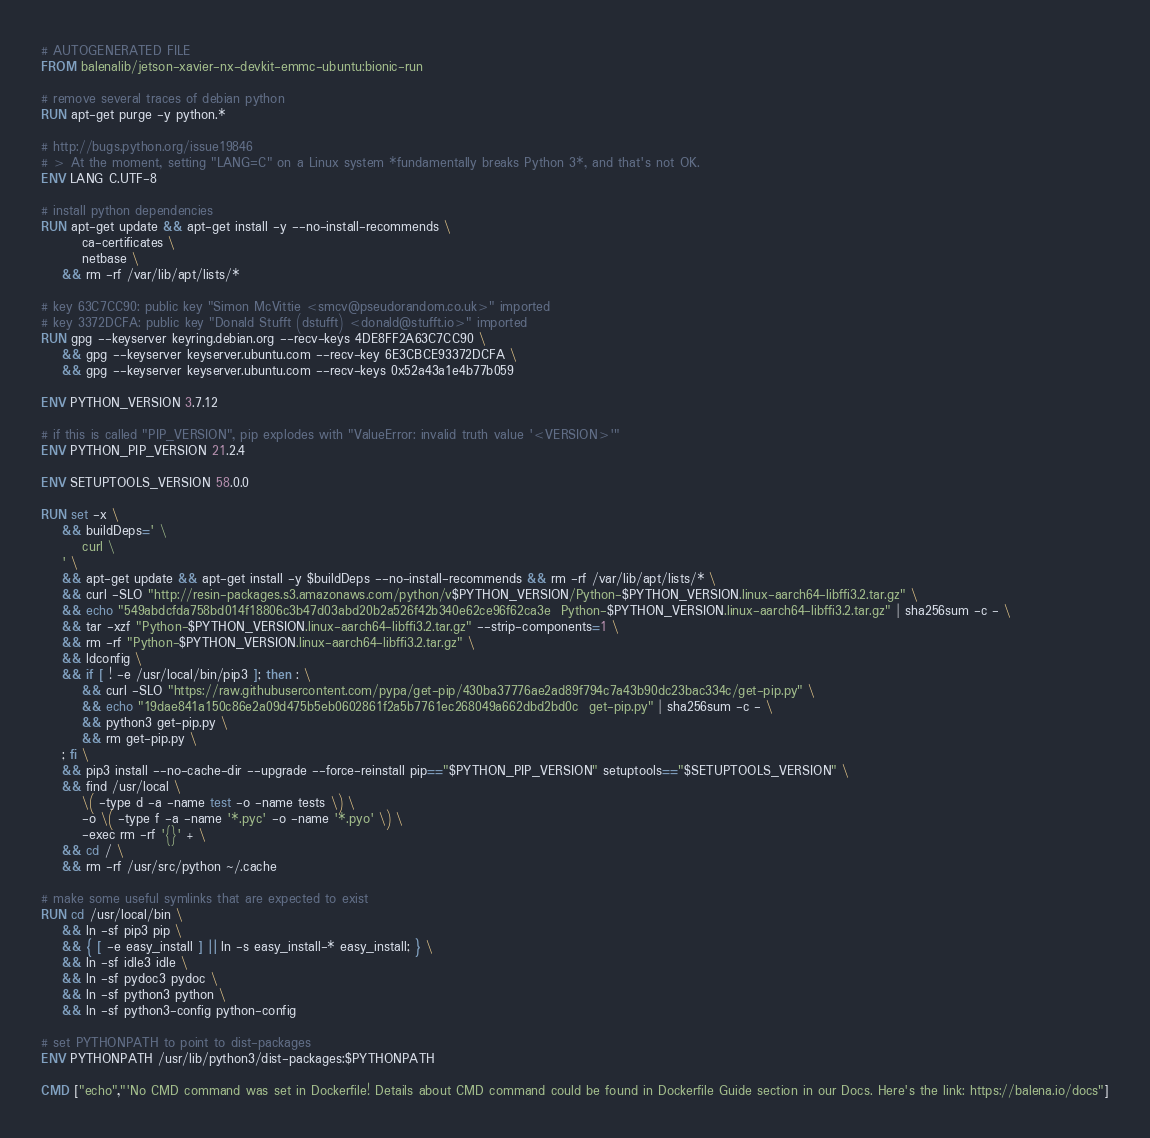<code> <loc_0><loc_0><loc_500><loc_500><_Dockerfile_># AUTOGENERATED FILE
FROM balenalib/jetson-xavier-nx-devkit-emmc-ubuntu:bionic-run

# remove several traces of debian python
RUN apt-get purge -y python.*

# http://bugs.python.org/issue19846
# > At the moment, setting "LANG=C" on a Linux system *fundamentally breaks Python 3*, and that's not OK.
ENV LANG C.UTF-8

# install python dependencies
RUN apt-get update && apt-get install -y --no-install-recommends \
		ca-certificates \
		netbase \
	&& rm -rf /var/lib/apt/lists/*

# key 63C7CC90: public key "Simon McVittie <smcv@pseudorandom.co.uk>" imported
# key 3372DCFA: public key "Donald Stufft (dstufft) <donald@stufft.io>" imported
RUN gpg --keyserver keyring.debian.org --recv-keys 4DE8FF2A63C7CC90 \
	&& gpg --keyserver keyserver.ubuntu.com --recv-key 6E3CBCE93372DCFA \
	&& gpg --keyserver keyserver.ubuntu.com --recv-keys 0x52a43a1e4b77b059

ENV PYTHON_VERSION 3.7.12

# if this is called "PIP_VERSION", pip explodes with "ValueError: invalid truth value '<VERSION>'"
ENV PYTHON_PIP_VERSION 21.2.4

ENV SETUPTOOLS_VERSION 58.0.0

RUN set -x \
	&& buildDeps=' \
		curl \
	' \
	&& apt-get update && apt-get install -y $buildDeps --no-install-recommends && rm -rf /var/lib/apt/lists/* \
	&& curl -SLO "http://resin-packages.s3.amazonaws.com/python/v$PYTHON_VERSION/Python-$PYTHON_VERSION.linux-aarch64-libffi3.2.tar.gz" \
	&& echo "549abdcfda758bd014f18806c3b47d03abd20b2a526f42b340e62ce96f62ca3e  Python-$PYTHON_VERSION.linux-aarch64-libffi3.2.tar.gz" | sha256sum -c - \
	&& tar -xzf "Python-$PYTHON_VERSION.linux-aarch64-libffi3.2.tar.gz" --strip-components=1 \
	&& rm -rf "Python-$PYTHON_VERSION.linux-aarch64-libffi3.2.tar.gz" \
	&& ldconfig \
	&& if [ ! -e /usr/local/bin/pip3 ]; then : \
		&& curl -SLO "https://raw.githubusercontent.com/pypa/get-pip/430ba37776ae2ad89f794c7a43b90dc23bac334c/get-pip.py" \
		&& echo "19dae841a150c86e2a09d475b5eb0602861f2a5b7761ec268049a662dbd2bd0c  get-pip.py" | sha256sum -c - \
		&& python3 get-pip.py \
		&& rm get-pip.py \
	; fi \
	&& pip3 install --no-cache-dir --upgrade --force-reinstall pip=="$PYTHON_PIP_VERSION" setuptools=="$SETUPTOOLS_VERSION" \
	&& find /usr/local \
		\( -type d -a -name test -o -name tests \) \
		-o \( -type f -a -name '*.pyc' -o -name '*.pyo' \) \
		-exec rm -rf '{}' + \
	&& cd / \
	&& rm -rf /usr/src/python ~/.cache

# make some useful symlinks that are expected to exist
RUN cd /usr/local/bin \
	&& ln -sf pip3 pip \
	&& { [ -e easy_install ] || ln -s easy_install-* easy_install; } \
	&& ln -sf idle3 idle \
	&& ln -sf pydoc3 pydoc \
	&& ln -sf python3 python \
	&& ln -sf python3-config python-config

# set PYTHONPATH to point to dist-packages
ENV PYTHONPATH /usr/lib/python3/dist-packages:$PYTHONPATH

CMD ["echo","'No CMD command was set in Dockerfile! Details about CMD command could be found in Dockerfile Guide section in our Docs. Here's the link: https://balena.io/docs"]
</code> 